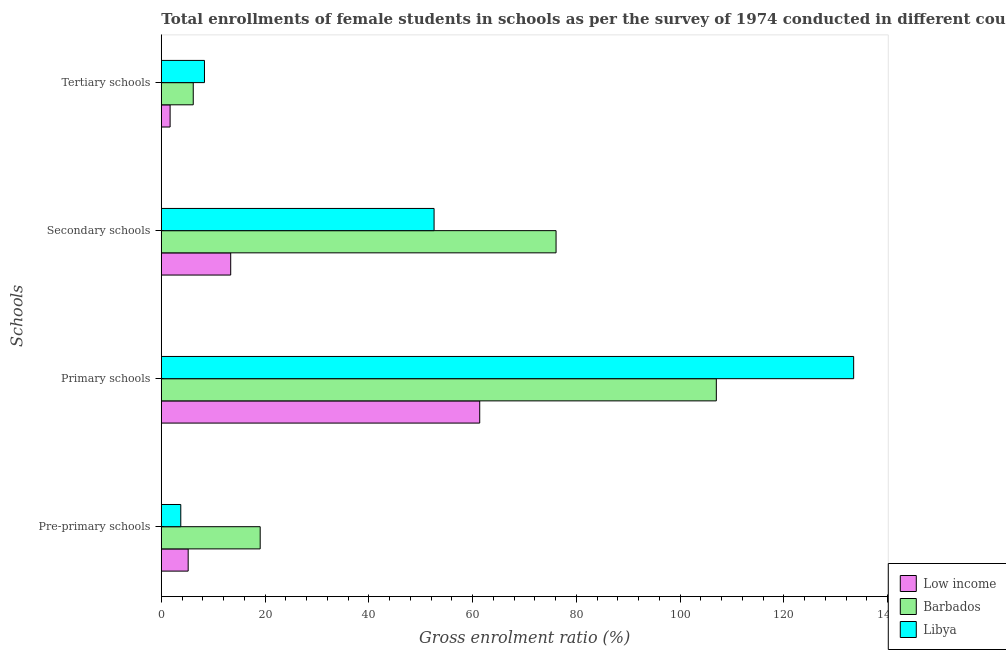How many different coloured bars are there?
Offer a terse response. 3. How many groups of bars are there?
Provide a succinct answer. 4. Are the number of bars on each tick of the Y-axis equal?
Make the answer very short. Yes. How many bars are there on the 3rd tick from the top?
Your answer should be compact. 3. What is the label of the 2nd group of bars from the top?
Your answer should be very brief. Secondary schools. What is the gross enrolment ratio(female) in primary schools in Low income?
Offer a terse response. 61.38. Across all countries, what is the maximum gross enrolment ratio(female) in tertiary schools?
Make the answer very short. 8.32. Across all countries, what is the minimum gross enrolment ratio(female) in primary schools?
Give a very brief answer. 61.38. In which country was the gross enrolment ratio(female) in secondary schools maximum?
Make the answer very short. Barbados. What is the total gross enrolment ratio(female) in tertiary schools in the graph?
Offer a terse response. 16.17. What is the difference between the gross enrolment ratio(female) in pre-primary schools in Barbados and that in Libya?
Offer a very short reply. 15.31. What is the difference between the gross enrolment ratio(female) in tertiary schools in Barbados and the gross enrolment ratio(female) in primary schools in Low income?
Offer a terse response. -55.23. What is the average gross enrolment ratio(female) in tertiary schools per country?
Ensure brevity in your answer.  5.39. What is the difference between the gross enrolment ratio(female) in tertiary schools and gross enrolment ratio(female) in secondary schools in Libya?
Offer a very short reply. -44.26. What is the ratio of the gross enrolment ratio(female) in secondary schools in Libya to that in Barbados?
Provide a succinct answer. 0.69. Is the difference between the gross enrolment ratio(female) in tertiary schools in Low income and Barbados greater than the difference between the gross enrolment ratio(female) in pre-primary schools in Low income and Barbados?
Offer a very short reply. Yes. What is the difference between the highest and the second highest gross enrolment ratio(female) in tertiary schools?
Give a very brief answer. 2.16. What is the difference between the highest and the lowest gross enrolment ratio(female) in primary schools?
Offer a terse response. 72.09. In how many countries, is the gross enrolment ratio(female) in tertiary schools greater than the average gross enrolment ratio(female) in tertiary schools taken over all countries?
Provide a short and direct response. 2. Is it the case that in every country, the sum of the gross enrolment ratio(female) in pre-primary schools and gross enrolment ratio(female) in tertiary schools is greater than the sum of gross enrolment ratio(female) in primary schools and gross enrolment ratio(female) in secondary schools?
Keep it short and to the point. No. What does the 2nd bar from the top in Primary schools represents?
Provide a succinct answer. Barbados. What does the 1st bar from the bottom in Pre-primary schools represents?
Ensure brevity in your answer.  Low income. How many bars are there?
Provide a succinct answer. 12. Are the values on the major ticks of X-axis written in scientific E-notation?
Give a very brief answer. No. Does the graph contain any zero values?
Give a very brief answer. No. How are the legend labels stacked?
Provide a short and direct response. Vertical. What is the title of the graph?
Your answer should be compact. Total enrollments of female students in schools as per the survey of 1974 conducted in different countries. Does "Cote d'Ivoire" appear as one of the legend labels in the graph?
Offer a terse response. No. What is the label or title of the Y-axis?
Provide a succinct answer. Schools. What is the Gross enrolment ratio (%) of Low income in Pre-primary schools?
Your answer should be compact. 5.18. What is the Gross enrolment ratio (%) of Barbados in Pre-primary schools?
Ensure brevity in your answer.  19.06. What is the Gross enrolment ratio (%) of Libya in Pre-primary schools?
Provide a succinct answer. 3.75. What is the Gross enrolment ratio (%) in Low income in Primary schools?
Keep it short and to the point. 61.38. What is the Gross enrolment ratio (%) in Barbados in Primary schools?
Keep it short and to the point. 107. What is the Gross enrolment ratio (%) in Libya in Primary schools?
Give a very brief answer. 133.47. What is the Gross enrolment ratio (%) of Low income in Secondary schools?
Provide a short and direct response. 13.38. What is the Gross enrolment ratio (%) of Barbados in Secondary schools?
Provide a succinct answer. 76.1. What is the Gross enrolment ratio (%) in Libya in Secondary schools?
Keep it short and to the point. 52.58. What is the Gross enrolment ratio (%) in Low income in Tertiary schools?
Your response must be concise. 1.7. What is the Gross enrolment ratio (%) in Barbados in Tertiary schools?
Make the answer very short. 6.16. What is the Gross enrolment ratio (%) in Libya in Tertiary schools?
Your answer should be compact. 8.32. Across all Schools, what is the maximum Gross enrolment ratio (%) in Low income?
Offer a very short reply. 61.38. Across all Schools, what is the maximum Gross enrolment ratio (%) in Barbados?
Provide a succinct answer. 107. Across all Schools, what is the maximum Gross enrolment ratio (%) of Libya?
Keep it short and to the point. 133.47. Across all Schools, what is the minimum Gross enrolment ratio (%) of Low income?
Provide a short and direct response. 1.7. Across all Schools, what is the minimum Gross enrolment ratio (%) of Barbados?
Your response must be concise. 6.16. Across all Schools, what is the minimum Gross enrolment ratio (%) of Libya?
Offer a terse response. 3.75. What is the total Gross enrolment ratio (%) of Low income in the graph?
Make the answer very short. 81.64. What is the total Gross enrolment ratio (%) of Barbados in the graph?
Your response must be concise. 208.32. What is the total Gross enrolment ratio (%) of Libya in the graph?
Ensure brevity in your answer.  198.13. What is the difference between the Gross enrolment ratio (%) in Low income in Pre-primary schools and that in Primary schools?
Offer a very short reply. -56.21. What is the difference between the Gross enrolment ratio (%) of Barbados in Pre-primary schools and that in Primary schools?
Provide a short and direct response. -87.94. What is the difference between the Gross enrolment ratio (%) of Libya in Pre-primary schools and that in Primary schools?
Your answer should be very brief. -129.72. What is the difference between the Gross enrolment ratio (%) of Low income in Pre-primary schools and that in Secondary schools?
Your answer should be very brief. -8.2. What is the difference between the Gross enrolment ratio (%) of Barbados in Pre-primary schools and that in Secondary schools?
Give a very brief answer. -57.04. What is the difference between the Gross enrolment ratio (%) of Libya in Pre-primary schools and that in Secondary schools?
Your answer should be compact. -48.83. What is the difference between the Gross enrolment ratio (%) in Low income in Pre-primary schools and that in Tertiary schools?
Your answer should be compact. 3.48. What is the difference between the Gross enrolment ratio (%) in Barbados in Pre-primary schools and that in Tertiary schools?
Offer a terse response. 12.9. What is the difference between the Gross enrolment ratio (%) of Libya in Pre-primary schools and that in Tertiary schools?
Give a very brief answer. -4.57. What is the difference between the Gross enrolment ratio (%) of Low income in Primary schools and that in Secondary schools?
Provide a short and direct response. 48.01. What is the difference between the Gross enrolment ratio (%) in Barbados in Primary schools and that in Secondary schools?
Keep it short and to the point. 30.9. What is the difference between the Gross enrolment ratio (%) in Libya in Primary schools and that in Secondary schools?
Provide a short and direct response. 80.89. What is the difference between the Gross enrolment ratio (%) in Low income in Primary schools and that in Tertiary schools?
Provide a short and direct response. 59.69. What is the difference between the Gross enrolment ratio (%) in Barbados in Primary schools and that in Tertiary schools?
Give a very brief answer. 100.84. What is the difference between the Gross enrolment ratio (%) of Libya in Primary schools and that in Tertiary schools?
Your answer should be compact. 125.15. What is the difference between the Gross enrolment ratio (%) in Low income in Secondary schools and that in Tertiary schools?
Your answer should be compact. 11.68. What is the difference between the Gross enrolment ratio (%) in Barbados in Secondary schools and that in Tertiary schools?
Give a very brief answer. 69.95. What is the difference between the Gross enrolment ratio (%) of Libya in Secondary schools and that in Tertiary schools?
Ensure brevity in your answer.  44.26. What is the difference between the Gross enrolment ratio (%) in Low income in Pre-primary schools and the Gross enrolment ratio (%) in Barbados in Primary schools?
Keep it short and to the point. -101.82. What is the difference between the Gross enrolment ratio (%) in Low income in Pre-primary schools and the Gross enrolment ratio (%) in Libya in Primary schools?
Your answer should be very brief. -128.3. What is the difference between the Gross enrolment ratio (%) of Barbados in Pre-primary schools and the Gross enrolment ratio (%) of Libya in Primary schools?
Provide a short and direct response. -114.41. What is the difference between the Gross enrolment ratio (%) of Low income in Pre-primary schools and the Gross enrolment ratio (%) of Barbados in Secondary schools?
Your answer should be compact. -70.92. What is the difference between the Gross enrolment ratio (%) of Low income in Pre-primary schools and the Gross enrolment ratio (%) of Libya in Secondary schools?
Ensure brevity in your answer.  -47.41. What is the difference between the Gross enrolment ratio (%) in Barbados in Pre-primary schools and the Gross enrolment ratio (%) in Libya in Secondary schools?
Provide a short and direct response. -33.52. What is the difference between the Gross enrolment ratio (%) in Low income in Pre-primary schools and the Gross enrolment ratio (%) in Barbados in Tertiary schools?
Give a very brief answer. -0.98. What is the difference between the Gross enrolment ratio (%) of Low income in Pre-primary schools and the Gross enrolment ratio (%) of Libya in Tertiary schools?
Offer a terse response. -3.14. What is the difference between the Gross enrolment ratio (%) in Barbados in Pre-primary schools and the Gross enrolment ratio (%) in Libya in Tertiary schools?
Offer a terse response. 10.74. What is the difference between the Gross enrolment ratio (%) in Low income in Primary schools and the Gross enrolment ratio (%) in Barbados in Secondary schools?
Your response must be concise. -14.72. What is the difference between the Gross enrolment ratio (%) of Low income in Primary schools and the Gross enrolment ratio (%) of Libya in Secondary schools?
Your answer should be very brief. 8.8. What is the difference between the Gross enrolment ratio (%) of Barbados in Primary schools and the Gross enrolment ratio (%) of Libya in Secondary schools?
Provide a short and direct response. 54.41. What is the difference between the Gross enrolment ratio (%) of Low income in Primary schools and the Gross enrolment ratio (%) of Barbados in Tertiary schools?
Make the answer very short. 55.23. What is the difference between the Gross enrolment ratio (%) in Low income in Primary schools and the Gross enrolment ratio (%) in Libya in Tertiary schools?
Provide a succinct answer. 53.06. What is the difference between the Gross enrolment ratio (%) in Barbados in Primary schools and the Gross enrolment ratio (%) in Libya in Tertiary schools?
Offer a terse response. 98.68. What is the difference between the Gross enrolment ratio (%) in Low income in Secondary schools and the Gross enrolment ratio (%) in Barbados in Tertiary schools?
Make the answer very short. 7.22. What is the difference between the Gross enrolment ratio (%) in Low income in Secondary schools and the Gross enrolment ratio (%) in Libya in Tertiary schools?
Provide a succinct answer. 5.06. What is the difference between the Gross enrolment ratio (%) in Barbados in Secondary schools and the Gross enrolment ratio (%) in Libya in Tertiary schools?
Keep it short and to the point. 67.78. What is the average Gross enrolment ratio (%) of Low income per Schools?
Offer a very short reply. 20.41. What is the average Gross enrolment ratio (%) in Barbados per Schools?
Give a very brief answer. 52.08. What is the average Gross enrolment ratio (%) in Libya per Schools?
Offer a very short reply. 49.53. What is the difference between the Gross enrolment ratio (%) in Low income and Gross enrolment ratio (%) in Barbados in Pre-primary schools?
Provide a short and direct response. -13.88. What is the difference between the Gross enrolment ratio (%) in Low income and Gross enrolment ratio (%) in Libya in Pre-primary schools?
Provide a short and direct response. 1.42. What is the difference between the Gross enrolment ratio (%) in Barbados and Gross enrolment ratio (%) in Libya in Pre-primary schools?
Ensure brevity in your answer.  15.31. What is the difference between the Gross enrolment ratio (%) of Low income and Gross enrolment ratio (%) of Barbados in Primary schools?
Your response must be concise. -45.61. What is the difference between the Gross enrolment ratio (%) of Low income and Gross enrolment ratio (%) of Libya in Primary schools?
Make the answer very short. -72.09. What is the difference between the Gross enrolment ratio (%) in Barbados and Gross enrolment ratio (%) in Libya in Primary schools?
Keep it short and to the point. -26.48. What is the difference between the Gross enrolment ratio (%) of Low income and Gross enrolment ratio (%) of Barbados in Secondary schools?
Your answer should be compact. -62.72. What is the difference between the Gross enrolment ratio (%) of Low income and Gross enrolment ratio (%) of Libya in Secondary schools?
Give a very brief answer. -39.21. What is the difference between the Gross enrolment ratio (%) of Barbados and Gross enrolment ratio (%) of Libya in Secondary schools?
Offer a terse response. 23.52. What is the difference between the Gross enrolment ratio (%) in Low income and Gross enrolment ratio (%) in Barbados in Tertiary schools?
Make the answer very short. -4.46. What is the difference between the Gross enrolment ratio (%) in Low income and Gross enrolment ratio (%) in Libya in Tertiary schools?
Provide a succinct answer. -6.62. What is the difference between the Gross enrolment ratio (%) in Barbados and Gross enrolment ratio (%) in Libya in Tertiary schools?
Offer a terse response. -2.16. What is the ratio of the Gross enrolment ratio (%) in Low income in Pre-primary schools to that in Primary schools?
Offer a very short reply. 0.08. What is the ratio of the Gross enrolment ratio (%) of Barbados in Pre-primary schools to that in Primary schools?
Your response must be concise. 0.18. What is the ratio of the Gross enrolment ratio (%) in Libya in Pre-primary schools to that in Primary schools?
Ensure brevity in your answer.  0.03. What is the ratio of the Gross enrolment ratio (%) in Low income in Pre-primary schools to that in Secondary schools?
Give a very brief answer. 0.39. What is the ratio of the Gross enrolment ratio (%) of Barbados in Pre-primary schools to that in Secondary schools?
Offer a terse response. 0.25. What is the ratio of the Gross enrolment ratio (%) in Libya in Pre-primary schools to that in Secondary schools?
Your answer should be compact. 0.07. What is the ratio of the Gross enrolment ratio (%) in Low income in Pre-primary schools to that in Tertiary schools?
Offer a terse response. 3.05. What is the ratio of the Gross enrolment ratio (%) of Barbados in Pre-primary schools to that in Tertiary schools?
Your response must be concise. 3.1. What is the ratio of the Gross enrolment ratio (%) of Libya in Pre-primary schools to that in Tertiary schools?
Your answer should be very brief. 0.45. What is the ratio of the Gross enrolment ratio (%) of Low income in Primary schools to that in Secondary schools?
Your answer should be compact. 4.59. What is the ratio of the Gross enrolment ratio (%) in Barbados in Primary schools to that in Secondary schools?
Your answer should be compact. 1.41. What is the ratio of the Gross enrolment ratio (%) of Libya in Primary schools to that in Secondary schools?
Your answer should be compact. 2.54. What is the ratio of the Gross enrolment ratio (%) of Low income in Primary schools to that in Tertiary schools?
Make the answer very short. 36.18. What is the ratio of the Gross enrolment ratio (%) in Barbados in Primary schools to that in Tertiary schools?
Give a very brief answer. 17.38. What is the ratio of the Gross enrolment ratio (%) in Libya in Primary schools to that in Tertiary schools?
Ensure brevity in your answer.  16.04. What is the ratio of the Gross enrolment ratio (%) of Low income in Secondary schools to that in Tertiary schools?
Your answer should be very brief. 7.89. What is the ratio of the Gross enrolment ratio (%) in Barbados in Secondary schools to that in Tertiary schools?
Offer a very short reply. 12.36. What is the ratio of the Gross enrolment ratio (%) in Libya in Secondary schools to that in Tertiary schools?
Provide a short and direct response. 6.32. What is the difference between the highest and the second highest Gross enrolment ratio (%) in Low income?
Your answer should be compact. 48.01. What is the difference between the highest and the second highest Gross enrolment ratio (%) in Barbados?
Keep it short and to the point. 30.9. What is the difference between the highest and the second highest Gross enrolment ratio (%) of Libya?
Make the answer very short. 80.89. What is the difference between the highest and the lowest Gross enrolment ratio (%) in Low income?
Keep it short and to the point. 59.69. What is the difference between the highest and the lowest Gross enrolment ratio (%) of Barbados?
Your answer should be compact. 100.84. What is the difference between the highest and the lowest Gross enrolment ratio (%) in Libya?
Make the answer very short. 129.72. 